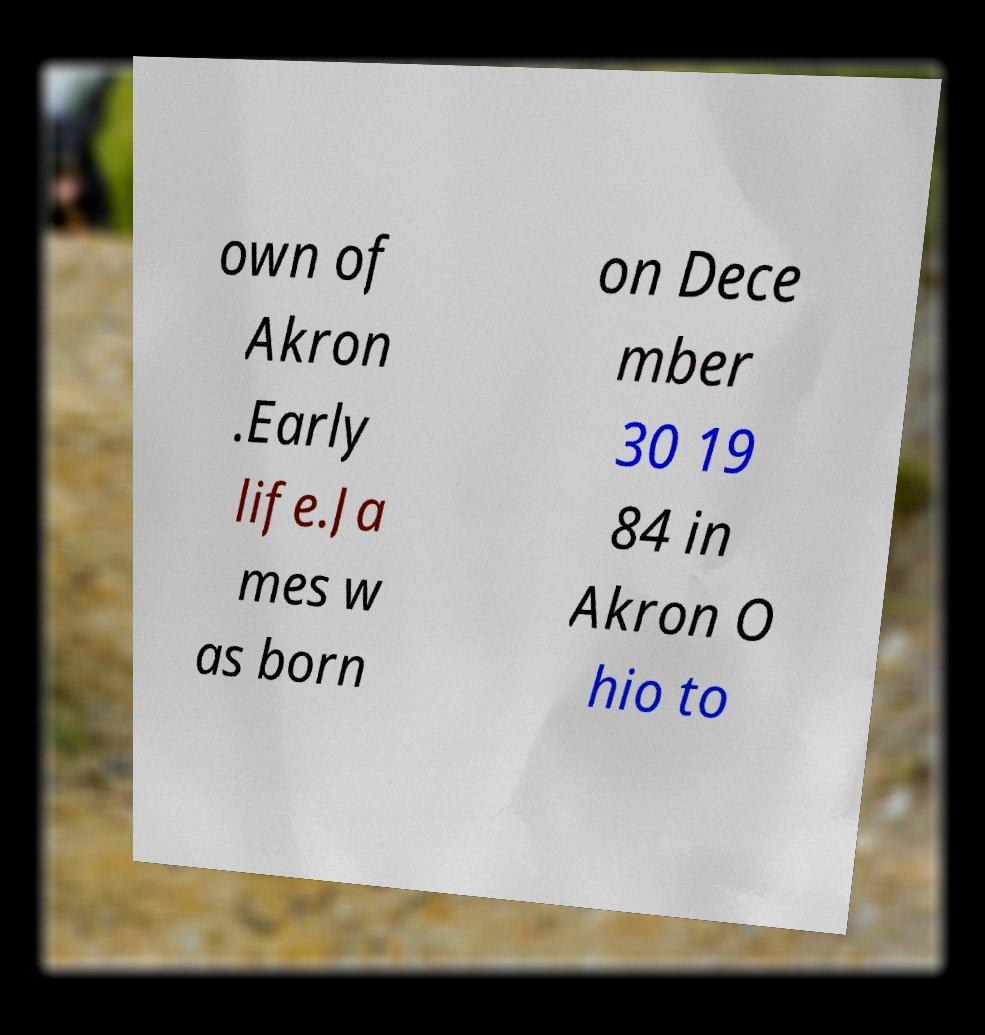What messages or text are displayed in this image? I need them in a readable, typed format. own of Akron .Early life.Ja mes w as born on Dece mber 30 19 84 in Akron O hio to 